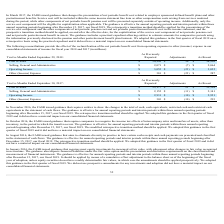According to Tyson Foods's financial document, Did the adoption of the new FASB issued guidances have a material impact on the firm's consolidated financial statements?  According to the financial document, No. The relevant text states: "pension and other postretirement benefit plan footnote. We adopted this guidance in the first quarter of fiscal 2019 on a retrospective basis using the pension and other postretirement benefit plan fo..." Also, What guidance did the FASB issue in November 2016? In November 2016, the FASB issued guidance that requires entities to show the changes in the total of cash, cash equivalents, restricted cash and restricted cash equivalents in the statement of cash flows.. The document states: "In November 2016, the FASB issued guidance that requires entities to show the changes in the total of cash, cash equivalents, restricted cash and rest..." Also, What guidance did the FASB issue in August 2016? In August 2016, the FASB issued guidance that aims to eliminate diversity in practice in how certain cash receipts and cash payments are presented and classified in the statement of cash flows.. The document states: "In August 2016, the FASB issued guidance that aims to eliminate diversity in practice in how certain cash receipts and cash payments are presented and..." Also, can you calculate: What is the percentage change between the cost of sales previously reported in 2017 and 2018? To answer this question, I need to perform calculations using the financial data. The calculation is: ($34,926-$33,177)/$33,177, which equals 5.27 (percentage). This is based on the information: "Cost of Sales $ 34,926 $ 30 $ 34,956 Cost of Sales $ 33,177 $ 21 $ 33,198..." The key data points involved are: 33,177, 34,926. Also, can you calculate: What is the  percentage change between the cost of sales as recasted in 2017 and 2018? To answer this question, I need to perform calculations using the financial data. The calculation is: ($34,956-$33,198)/$33,198, which equals 5.3 (percentage). This is based on the information: "Cost of Sales $ 33,177 $ 21 $ 33,198 Cost of Sales $ 34,926 $ 30 $ 34,956..." The key data points involved are: 33,198, 34,956. Also, can you calculate: What is the difference between the operating income as recasted in 2017 and 2018? To answer this question, I need to perform calculations using the financial data. The calculation is: ($3,032-$2,921)/$2,921, which equals 3.8 (percentage). This is based on the information: "Operating Income $ 2,931 $ (10) $ 2,921 Operating Income $ 3,055 $ (23) $ 3,032..." The key data points involved are: 2,921, 3,032. 